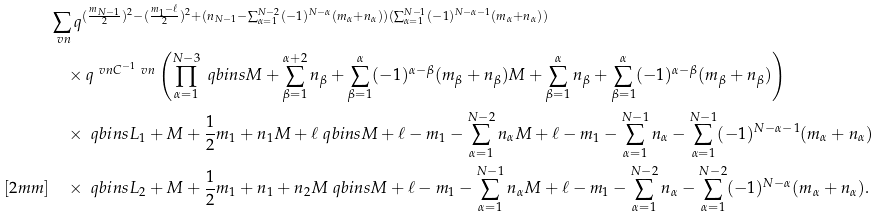Convert formula to latex. <formula><loc_0><loc_0><loc_500><loc_500>& \sum _ { \ v n } q ^ { ( \frac { m _ { N - 1 } } { 2 } ) ^ { 2 } - ( \frac { m _ { 1 } - \ell } { 2 } ) ^ { 2 } + ( n _ { N - 1 } - \sum _ { \alpha = 1 } ^ { N - 2 } ( - 1 ) ^ { N - \alpha } ( m _ { \alpha } + n _ { \alpha } ) ) ( \sum _ { \alpha = 1 } ^ { N - 1 } ( - 1 ) ^ { N - \alpha - 1 } ( m _ { \alpha } + n _ { \alpha } ) ) } \\ & \quad \times q ^ { \ v n C ^ { - 1 } \ v n } \left ( \prod _ { \alpha = 1 } ^ { N - 3 } \ q b i n s { M + \sum _ { \beta = 1 } ^ { \alpha + 2 } n _ { \beta } + \sum _ { \beta = 1 } ^ { \alpha } ( - 1 ) ^ { \alpha - \beta } ( m _ { \beta } + n _ { \beta } ) } { M + \sum _ { \beta = 1 } ^ { \alpha } n _ { \beta } + \sum _ { \beta = 1 } ^ { \alpha } ( - 1 ) ^ { \alpha - \beta } ( m _ { \beta } + n _ { \beta } ) } \right ) \\ & \quad \times \ q b i n s { L _ { 1 } + M + \frac { 1 } { 2 } m _ { 1 } + n _ { 1 } } { M + \ell } \ q b i n s { M + \ell - m _ { 1 } - \sum _ { \alpha = 1 } ^ { N - 2 } n _ { \alpha } } { M + \ell - m _ { 1 } - \sum _ { \alpha = 1 } ^ { N - 1 } n _ { \alpha } - \sum _ { \alpha = 1 } ^ { N - 1 } ( - 1 ) ^ { N - \alpha - 1 } ( m _ { \alpha } + n _ { \alpha } ) } \\ [ 2 m m ] & \quad \times \ q b i n s { L _ { 2 } + M + \frac { 1 } { 2 } m _ { 1 } + n _ { 1 } + n _ { 2 } } { M } \ q b i n s { M + \ell - m _ { 1 } - \sum _ { \alpha = 1 } ^ { N - 1 } n _ { \alpha } } { M + \ell - m _ { 1 } - \sum _ { \alpha = 1 } ^ { N - 2 } n _ { \alpha } - \sum _ { \alpha = 1 } ^ { N - 2 } ( - 1 ) ^ { N - \alpha } ( m _ { \alpha } + n _ { \alpha } ) } .</formula> 